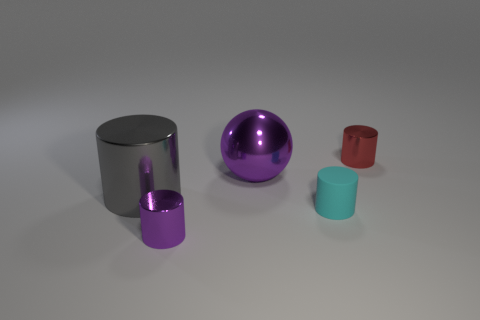Add 1 green objects. How many objects exist? 6 Subtract all spheres. How many objects are left? 4 Subtract 0 gray blocks. How many objects are left? 5 Subtract all large gray shiny objects. Subtract all rubber objects. How many objects are left? 3 Add 2 big purple metallic objects. How many big purple metallic objects are left? 3 Add 5 purple shiny objects. How many purple shiny objects exist? 7 